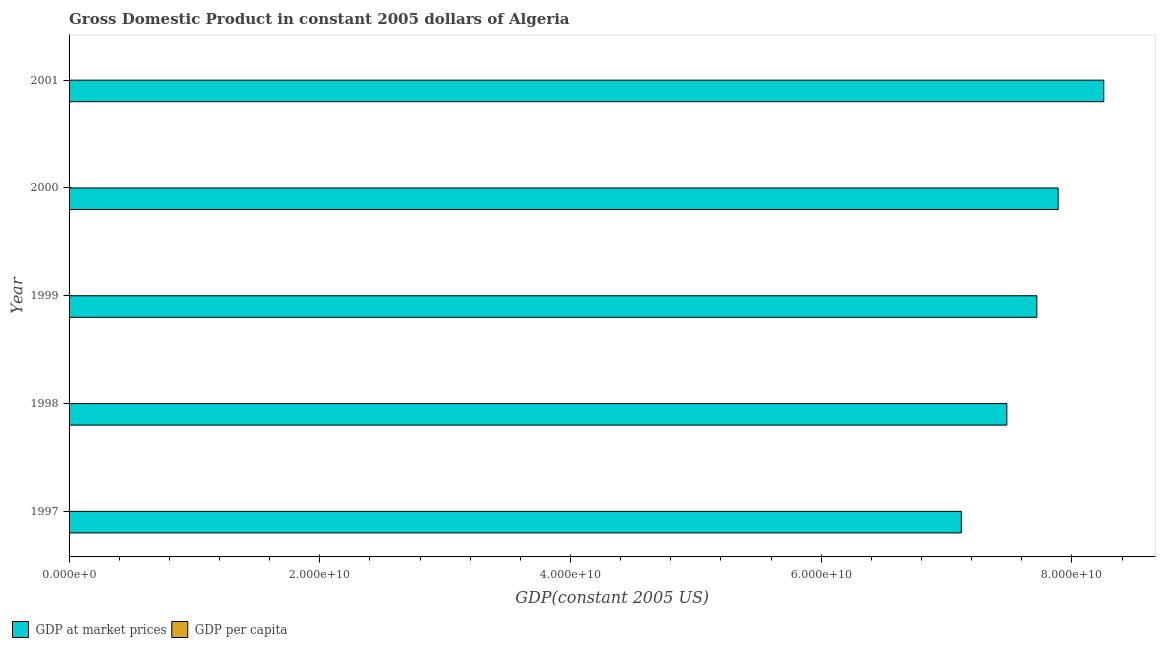How many different coloured bars are there?
Provide a succinct answer. 2. How many groups of bars are there?
Ensure brevity in your answer.  5. Are the number of bars per tick equal to the number of legend labels?
Keep it short and to the point. Yes. How many bars are there on the 3rd tick from the bottom?
Provide a short and direct response. 2. What is the gdp per capita in 2000?
Make the answer very short. 2530.01. Across all years, what is the maximum gdp at market prices?
Provide a succinct answer. 8.25e+1. Across all years, what is the minimum gdp per capita?
Your answer should be compact. 2381.35. In which year was the gdp per capita maximum?
Provide a short and direct response. 2001. In which year was the gdp per capita minimum?
Ensure brevity in your answer.  1997. What is the total gdp per capita in the graph?
Ensure brevity in your answer.  1.25e+04. What is the difference between the gdp at market prices in 1998 and that in 1999?
Offer a terse response. -2.39e+09. What is the difference between the gdp at market prices in 2000 and the gdp per capita in 2001?
Keep it short and to the point. 7.89e+1. What is the average gdp per capita per year?
Offer a terse response. 2499.77. In the year 1998, what is the difference between the gdp per capita and gdp at market prices?
Offer a very short reply. -7.48e+1. What is the ratio of the gdp at market prices in 1999 to that in 2001?
Make the answer very short. 0.94. Is the gdp at market prices in 1997 less than that in 2001?
Offer a very short reply. Yes. What is the difference between the highest and the second highest gdp at market prices?
Offer a very short reply. 3.64e+09. What is the difference between the highest and the lowest gdp at market prices?
Your answer should be very brief. 1.14e+1. Is the sum of the gdp at market prices in 1998 and 2000 greater than the maximum gdp per capita across all years?
Offer a terse response. Yes. What does the 1st bar from the top in 1997 represents?
Ensure brevity in your answer.  GDP per capita. What does the 1st bar from the bottom in 2001 represents?
Keep it short and to the point. GDP at market prices. How many bars are there?
Your response must be concise. 10. How many years are there in the graph?
Give a very brief answer. 5. What is the difference between two consecutive major ticks on the X-axis?
Offer a very short reply. 2.00e+1. Are the values on the major ticks of X-axis written in scientific E-notation?
Keep it short and to the point. Yes. Does the graph contain any zero values?
Give a very brief answer. No. Where does the legend appear in the graph?
Give a very brief answer. Bottom left. How many legend labels are there?
Your answer should be compact. 2. What is the title of the graph?
Provide a succinct answer. Gross Domestic Product in constant 2005 dollars of Algeria. What is the label or title of the X-axis?
Provide a succinct answer. GDP(constant 2005 US). What is the GDP(constant 2005 US) in GDP at market prices in 1997?
Give a very brief answer. 7.12e+1. What is the GDP(constant 2005 US) in GDP per capita in 1997?
Your answer should be compact. 2381.35. What is the GDP(constant 2005 US) of GDP at market prices in 1998?
Offer a very short reply. 7.48e+1. What is the GDP(constant 2005 US) in GDP per capita in 1998?
Provide a short and direct response. 2465.74. What is the GDP(constant 2005 US) of GDP at market prices in 1999?
Your answer should be very brief. 7.72e+1. What is the GDP(constant 2005 US) of GDP per capita in 1999?
Your response must be concise. 2509.11. What is the GDP(constant 2005 US) of GDP at market prices in 2000?
Keep it short and to the point. 7.89e+1. What is the GDP(constant 2005 US) of GDP per capita in 2000?
Your response must be concise. 2530.01. What is the GDP(constant 2005 US) in GDP at market prices in 2001?
Provide a succinct answer. 8.25e+1. What is the GDP(constant 2005 US) in GDP per capita in 2001?
Provide a succinct answer. 2612.64. Across all years, what is the maximum GDP(constant 2005 US) in GDP at market prices?
Your answer should be compact. 8.25e+1. Across all years, what is the maximum GDP(constant 2005 US) of GDP per capita?
Make the answer very short. 2612.64. Across all years, what is the minimum GDP(constant 2005 US) in GDP at market prices?
Offer a very short reply. 7.12e+1. Across all years, what is the minimum GDP(constant 2005 US) of GDP per capita?
Provide a short and direct response. 2381.35. What is the total GDP(constant 2005 US) in GDP at market prices in the graph?
Make the answer very short. 3.85e+11. What is the total GDP(constant 2005 US) in GDP per capita in the graph?
Offer a terse response. 1.25e+04. What is the difference between the GDP(constant 2005 US) in GDP at market prices in 1997 and that in 1998?
Offer a very short reply. -3.63e+09. What is the difference between the GDP(constant 2005 US) in GDP per capita in 1997 and that in 1998?
Your answer should be very brief. -84.39. What is the difference between the GDP(constant 2005 US) of GDP at market prices in 1997 and that in 1999?
Your answer should be compact. -6.02e+09. What is the difference between the GDP(constant 2005 US) of GDP per capita in 1997 and that in 1999?
Give a very brief answer. -127.76. What is the difference between the GDP(constant 2005 US) in GDP at market prices in 1997 and that in 2000?
Make the answer very short. -7.72e+09. What is the difference between the GDP(constant 2005 US) of GDP per capita in 1997 and that in 2000?
Offer a terse response. -148.66. What is the difference between the GDP(constant 2005 US) in GDP at market prices in 1997 and that in 2001?
Keep it short and to the point. -1.14e+1. What is the difference between the GDP(constant 2005 US) of GDP per capita in 1997 and that in 2001?
Offer a very short reply. -231.29. What is the difference between the GDP(constant 2005 US) of GDP at market prices in 1998 and that in 1999?
Offer a very short reply. -2.39e+09. What is the difference between the GDP(constant 2005 US) of GDP per capita in 1998 and that in 1999?
Provide a succinct answer. -43.37. What is the difference between the GDP(constant 2005 US) of GDP at market prices in 1998 and that in 2000?
Your response must be concise. -4.09e+09. What is the difference between the GDP(constant 2005 US) of GDP per capita in 1998 and that in 2000?
Provide a succinct answer. -64.27. What is the difference between the GDP(constant 2005 US) of GDP at market prices in 1998 and that in 2001?
Provide a succinct answer. -7.73e+09. What is the difference between the GDP(constant 2005 US) of GDP per capita in 1998 and that in 2001?
Provide a short and direct response. -146.89. What is the difference between the GDP(constant 2005 US) of GDP at market prices in 1999 and that in 2000?
Keep it short and to the point. -1.70e+09. What is the difference between the GDP(constant 2005 US) of GDP per capita in 1999 and that in 2000?
Your answer should be compact. -20.9. What is the difference between the GDP(constant 2005 US) of GDP at market prices in 1999 and that in 2001?
Your answer should be compact. -5.34e+09. What is the difference between the GDP(constant 2005 US) in GDP per capita in 1999 and that in 2001?
Your answer should be compact. -103.53. What is the difference between the GDP(constant 2005 US) in GDP at market prices in 2000 and that in 2001?
Offer a terse response. -3.64e+09. What is the difference between the GDP(constant 2005 US) in GDP per capita in 2000 and that in 2001?
Make the answer very short. -82.63. What is the difference between the GDP(constant 2005 US) in GDP at market prices in 1997 and the GDP(constant 2005 US) in GDP per capita in 1998?
Provide a succinct answer. 7.12e+1. What is the difference between the GDP(constant 2005 US) in GDP at market prices in 1997 and the GDP(constant 2005 US) in GDP per capita in 1999?
Offer a terse response. 7.12e+1. What is the difference between the GDP(constant 2005 US) of GDP at market prices in 1997 and the GDP(constant 2005 US) of GDP per capita in 2000?
Keep it short and to the point. 7.12e+1. What is the difference between the GDP(constant 2005 US) of GDP at market prices in 1997 and the GDP(constant 2005 US) of GDP per capita in 2001?
Offer a terse response. 7.12e+1. What is the difference between the GDP(constant 2005 US) in GDP at market prices in 1998 and the GDP(constant 2005 US) in GDP per capita in 1999?
Provide a succinct answer. 7.48e+1. What is the difference between the GDP(constant 2005 US) of GDP at market prices in 1998 and the GDP(constant 2005 US) of GDP per capita in 2000?
Offer a very short reply. 7.48e+1. What is the difference between the GDP(constant 2005 US) in GDP at market prices in 1998 and the GDP(constant 2005 US) in GDP per capita in 2001?
Keep it short and to the point. 7.48e+1. What is the difference between the GDP(constant 2005 US) in GDP at market prices in 1999 and the GDP(constant 2005 US) in GDP per capita in 2000?
Your answer should be very brief. 7.72e+1. What is the difference between the GDP(constant 2005 US) in GDP at market prices in 1999 and the GDP(constant 2005 US) in GDP per capita in 2001?
Offer a very short reply. 7.72e+1. What is the difference between the GDP(constant 2005 US) in GDP at market prices in 2000 and the GDP(constant 2005 US) in GDP per capita in 2001?
Ensure brevity in your answer.  7.89e+1. What is the average GDP(constant 2005 US) of GDP at market prices per year?
Ensure brevity in your answer.  7.69e+1. What is the average GDP(constant 2005 US) of GDP per capita per year?
Your response must be concise. 2499.77. In the year 1997, what is the difference between the GDP(constant 2005 US) in GDP at market prices and GDP(constant 2005 US) in GDP per capita?
Your response must be concise. 7.12e+1. In the year 1998, what is the difference between the GDP(constant 2005 US) in GDP at market prices and GDP(constant 2005 US) in GDP per capita?
Provide a succinct answer. 7.48e+1. In the year 1999, what is the difference between the GDP(constant 2005 US) of GDP at market prices and GDP(constant 2005 US) of GDP per capita?
Offer a very short reply. 7.72e+1. In the year 2000, what is the difference between the GDP(constant 2005 US) of GDP at market prices and GDP(constant 2005 US) of GDP per capita?
Offer a very short reply. 7.89e+1. In the year 2001, what is the difference between the GDP(constant 2005 US) of GDP at market prices and GDP(constant 2005 US) of GDP per capita?
Provide a succinct answer. 8.25e+1. What is the ratio of the GDP(constant 2005 US) in GDP at market prices in 1997 to that in 1998?
Keep it short and to the point. 0.95. What is the ratio of the GDP(constant 2005 US) in GDP per capita in 1997 to that in 1998?
Your response must be concise. 0.97. What is the ratio of the GDP(constant 2005 US) in GDP at market prices in 1997 to that in 1999?
Your answer should be compact. 0.92. What is the ratio of the GDP(constant 2005 US) of GDP per capita in 1997 to that in 1999?
Give a very brief answer. 0.95. What is the ratio of the GDP(constant 2005 US) of GDP at market prices in 1997 to that in 2000?
Your response must be concise. 0.9. What is the ratio of the GDP(constant 2005 US) of GDP at market prices in 1997 to that in 2001?
Offer a very short reply. 0.86. What is the ratio of the GDP(constant 2005 US) in GDP per capita in 1997 to that in 2001?
Give a very brief answer. 0.91. What is the ratio of the GDP(constant 2005 US) of GDP per capita in 1998 to that in 1999?
Give a very brief answer. 0.98. What is the ratio of the GDP(constant 2005 US) in GDP at market prices in 1998 to that in 2000?
Provide a short and direct response. 0.95. What is the ratio of the GDP(constant 2005 US) of GDP per capita in 1998 to that in 2000?
Offer a very short reply. 0.97. What is the ratio of the GDP(constant 2005 US) in GDP at market prices in 1998 to that in 2001?
Offer a terse response. 0.91. What is the ratio of the GDP(constant 2005 US) of GDP per capita in 1998 to that in 2001?
Offer a very short reply. 0.94. What is the ratio of the GDP(constant 2005 US) of GDP at market prices in 1999 to that in 2000?
Your answer should be compact. 0.98. What is the ratio of the GDP(constant 2005 US) of GDP per capita in 1999 to that in 2000?
Your response must be concise. 0.99. What is the ratio of the GDP(constant 2005 US) of GDP at market prices in 1999 to that in 2001?
Your answer should be very brief. 0.94. What is the ratio of the GDP(constant 2005 US) of GDP per capita in 1999 to that in 2001?
Your answer should be compact. 0.96. What is the ratio of the GDP(constant 2005 US) in GDP at market prices in 2000 to that in 2001?
Your response must be concise. 0.96. What is the ratio of the GDP(constant 2005 US) in GDP per capita in 2000 to that in 2001?
Your answer should be compact. 0.97. What is the difference between the highest and the second highest GDP(constant 2005 US) in GDP at market prices?
Ensure brevity in your answer.  3.64e+09. What is the difference between the highest and the second highest GDP(constant 2005 US) in GDP per capita?
Your answer should be very brief. 82.63. What is the difference between the highest and the lowest GDP(constant 2005 US) in GDP at market prices?
Your answer should be very brief. 1.14e+1. What is the difference between the highest and the lowest GDP(constant 2005 US) in GDP per capita?
Ensure brevity in your answer.  231.29. 